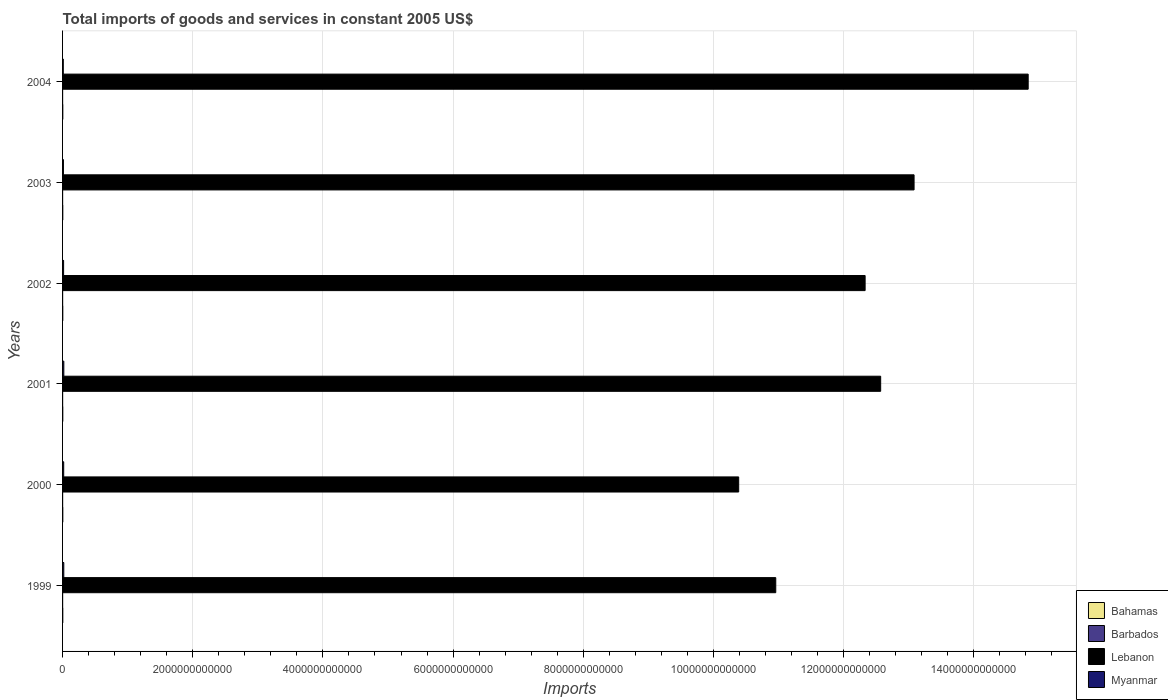How many different coloured bars are there?
Your response must be concise. 4. Are the number of bars on each tick of the Y-axis equal?
Provide a short and direct response. Yes. How many bars are there on the 1st tick from the top?
Give a very brief answer. 4. What is the total imports of goods and services in Lebanon in 1999?
Offer a very short reply. 1.10e+13. Across all years, what is the maximum total imports of goods and services in Barbados?
Ensure brevity in your answer.  8.21e+08. Across all years, what is the minimum total imports of goods and services in Lebanon?
Offer a very short reply. 1.04e+13. In which year was the total imports of goods and services in Bahamas maximum?
Your answer should be very brief. 2000. In which year was the total imports of goods and services in Bahamas minimum?
Offer a very short reply. 2002. What is the total total imports of goods and services in Lebanon in the graph?
Make the answer very short. 7.42e+13. What is the difference between the total imports of goods and services in Bahamas in 2001 and that in 2002?
Provide a succinct answer. 9.45e+07. What is the difference between the total imports of goods and services in Barbados in 2004 and the total imports of goods and services in Bahamas in 2003?
Provide a short and direct response. -2.55e+09. What is the average total imports of goods and services in Lebanon per year?
Keep it short and to the point. 1.24e+13. In the year 2003, what is the difference between the total imports of goods and services in Lebanon and total imports of goods and services in Barbados?
Your answer should be compact. 1.31e+13. What is the ratio of the total imports of goods and services in Barbados in 1999 to that in 2003?
Ensure brevity in your answer.  1.06. Is the total imports of goods and services in Lebanon in 2001 less than that in 2004?
Offer a very short reply. Yes. Is the difference between the total imports of goods and services in Lebanon in 2000 and 2004 greater than the difference between the total imports of goods and services in Barbados in 2000 and 2004?
Provide a short and direct response. No. What is the difference between the highest and the second highest total imports of goods and services in Myanmar?
Provide a succinct answer. 3.99e+08. What is the difference between the highest and the lowest total imports of goods and services in Bahamas?
Offer a terse response. 2.28e+08. In how many years, is the total imports of goods and services in Bahamas greater than the average total imports of goods and services in Bahamas taken over all years?
Ensure brevity in your answer.  3. Is the sum of the total imports of goods and services in Myanmar in 1999 and 2001 greater than the maximum total imports of goods and services in Barbados across all years?
Ensure brevity in your answer.  Yes. Is it the case that in every year, the sum of the total imports of goods and services in Myanmar and total imports of goods and services in Barbados is greater than the sum of total imports of goods and services in Lebanon and total imports of goods and services in Bahamas?
Provide a short and direct response. Yes. What does the 4th bar from the top in 2003 represents?
Provide a short and direct response. Bahamas. What does the 3rd bar from the bottom in 2002 represents?
Provide a succinct answer. Lebanon. Is it the case that in every year, the sum of the total imports of goods and services in Myanmar and total imports of goods and services in Bahamas is greater than the total imports of goods and services in Barbados?
Ensure brevity in your answer.  Yes. What is the difference between two consecutive major ticks on the X-axis?
Offer a very short reply. 2.00e+12. Does the graph contain any zero values?
Ensure brevity in your answer.  No. Where does the legend appear in the graph?
Offer a terse response. Bottom right. How many legend labels are there?
Keep it short and to the point. 4. What is the title of the graph?
Provide a short and direct response. Total imports of goods and services in constant 2005 US$. What is the label or title of the X-axis?
Make the answer very short. Imports. What is the Imports in Bahamas in 1999?
Your response must be concise. 3.36e+09. What is the Imports of Barbados in 1999?
Ensure brevity in your answer.  8.19e+08. What is the Imports of Lebanon in 1999?
Your answer should be very brief. 1.10e+13. What is the Imports of Myanmar in 1999?
Offer a very short reply. 1.90e+1. What is the Imports in Bahamas in 2000?
Ensure brevity in your answer.  3.54e+09. What is the Imports in Barbados in 2000?
Your response must be concise. 8.12e+08. What is the Imports of Lebanon in 2000?
Ensure brevity in your answer.  1.04e+13. What is the Imports of Myanmar in 2000?
Provide a succinct answer. 1.75e+1. What is the Imports of Bahamas in 2001?
Give a very brief answer. 3.41e+09. What is the Imports in Barbados in 2001?
Your answer should be very brief. 8.21e+08. What is the Imports of Lebanon in 2001?
Ensure brevity in your answer.  1.26e+13. What is the Imports in Myanmar in 2001?
Your answer should be compact. 1.94e+1. What is the Imports in Bahamas in 2002?
Provide a short and direct response. 3.32e+09. What is the Imports in Barbados in 2002?
Ensure brevity in your answer.  7.99e+08. What is the Imports in Lebanon in 2002?
Your answer should be compact. 1.23e+13. What is the Imports of Myanmar in 2002?
Make the answer very short. 1.60e+1. What is the Imports in Bahamas in 2003?
Provide a short and direct response. 3.33e+09. What is the Imports of Barbados in 2003?
Keep it short and to the point. 7.71e+08. What is the Imports in Lebanon in 2003?
Provide a short and direct response. 1.31e+13. What is the Imports in Myanmar in 2003?
Your answer should be compact. 1.35e+1. What is the Imports in Bahamas in 2004?
Give a very brief answer. 3.44e+09. What is the Imports of Barbados in 2004?
Provide a short and direct response. 7.75e+08. What is the Imports of Lebanon in 2004?
Give a very brief answer. 1.48e+13. What is the Imports of Myanmar in 2004?
Your answer should be very brief. 1.13e+1. Across all years, what is the maximum Imports in Bahamas?
Your response must be concise. 3.54e+09. Across all years, what is the maximum Imports in Barbados?
Offer a very short reply. 8.21e+08. Across all years, what is the maximum Imports in Lebanon?
Make the answer very short. 1.48e+13. Across all years, what is the maximum Imports in Myanmar?
Your answer should be very brief. 1.94e+1. Across all years, what is the minimum Imports of Bahamas?
Give a very brief answer. 3.32e+09. Across all years, what is the minimum Imports of Barbados?
Provide a short and direct response. 7.71e+08. Across all years, what is the minimum Imports of Lebanon?
Your response must be concise. 1.04e+13. Across all years, what is the minimum Imports in Myanmar?
Make the answer very short. 1.13e+1. What is the total Imports of Bahamas in the graph?
Ensure brevity in your answer.  2.04e+1. What is the total Imports in Barbados in the graph?
Offer a terse response. 4.80e+09. What is the total Imports of Lebanon in the graph?
Keep it short and to the point. 7.42e+13. What is the total Imports in Myanmar in the graph?
Give a very brief answer. 9.67e+1. What is the difference between the Imports of Bahamas in 1999 and that in 2000?
Offer a terse response. -1.84e+08. What is the difference between the Imports in Barbados in 1999 and that in 2000?
Make the answer very short. 7.00e+06. What is the difference between the Imports in Lebanon in 1999 and that in 2000?
Provide a succinct answer. 5.70e+11. What is the difference between the Imports in Myanmar in 1999 and that in 2000?
Your answer should be very brief. 1.52e+09. What is the difference between the Imports of Bahamas in 1999 and that in 2001?
Provide a short and direct response. -5.04e+07. What is the difference between the Imports of Barbados in 1999 and that in 2001?
Your answer should be very brief. -2.00e+06. What is the difference between the Imports in Lebanon in 1999 and that in 2001?
Provide a succinct answer. -1.61e+12. What is the difference between the Imports in Myanmar in 1999 and that in 2001?
Offer a very short reply. -3.99e+08. What is the difference between the Imports in Bahamas in 1999 and that in 2002?
Give a very brief answer. 4.41e+07. What is the difference between the Imports in Barbados in 1999 and that in 2002?
Give a very brief answer. 2.00e+07. What is the difference between the Imports of Lebanon in 1999 and that in 2002?
Your answer should be compact. -1.37e+12. What is the difference between the Imports of Myanmar in 1999 and that in 2002?
Offer a terse response. 3.00e+09. What is the difference between the Imports in Bahamas in 1999 and that in 2003?
Make the answer very short. 3.28e+07. What is the difference between the Imports of Barbados in 1999 and that in 2003?
Your answer should be very brief. 4.80e+07. What is the difference between the Imports in Lebanon in 1999 and that in 2003?
Give a very brief answer. -2.12e+12. What is the difference between the Imports in Myanmar in 1999 and that in 2003?
Offer a very short reply. 5.53e+09. What is the difference between the Imports of Bahamas in 1999 and that in 2004?
Ensure brevity in your answer.  -8.50e+07. What is the difference between the Imports in Barbados in 1999 and that in 2004?
Provide a succinct answer. 4.40e+07. What is the difference between the Imports of Lebanon in 1999 and that in 2004?
Keep it short and to the point. -3.88e+12. What is the difference between the Imports in Myanmar in 1999 and that in 2004?
Provide a short and direct response. 7.72e+09. What is the difference between the Imports in Bahamas in 2000 and that in 2001?
Keep it short and to the point. 1.34e+08. What is the difference between the Imports of Barbados in 2000 and that in 2001?
Offer a very short reply. -9.00e+06. What is the difference between the Imports in Lebanon in 2000 and that in 2001?
Offer a terse response. -2.18e+12. What is the difference between the Imports of Myanmar in 2000 and that in 2001?
Offer a terse response. -1.92e+09. What is the difference between the Imports of Bahamas in 2000 and that in 2002?
Your response must be concise. 2.28e+08. What is the difference between the Imports in Barbados in 2000 and that in 2002?
Ensure brevity in your answer.  1.30e+07. What is the difference between the Imports in Lebanon in 2000 and that in 2002?
Your response must be concise. -1.94e+12. What is the difference between the Imports of Myanmar in 2000 and that in 2002?
Offer a very short reply. 1.48e+09. What is the difference between the Imports of Bahamas in 2000 and that in 2003?
Keep it short and to the point. 2.17e+08. What is the difference between the Imports in Barbados in 2000 and that in 2003?
Offer a terse response. 4.10e+07. What is the difference between the Imports in Lebanon in 2000 and that in 2003?
Provide a succinct answer. -2.69e+12. What is the difference between the Imports of Myanmar in 2000 and that in 2003?
Offer a terse response. 4.01e+09. What is the difference between the Imports of Bahamas in 2000 and that in 2004?
Offer a terse response. 9.93e+07. What is the difference between the Imports of Barbados in 2000 and that in 2004?
Keep it short and to the point. 3.70e+07. What is the difference between the Imports of Lebanon in 2000 and that in 2004?
Make the answer very short. -4.45e+12. What is the difference between the Imports of Myanmar in 2000 and that in 2004?
Provide a short and direct response. 6.20e+09. What is the difference between the Imports of Bahamas in 2001 and that in 2002?
Make the answer very short. 9.45e+07. What is the difference between the Imports of Barbados in 2001 and that in 2002?
Provide a succinct answer. 2.20e+07. What is the difference between the Imports in Lebanon in 2001 and that in 2002?
Give a very brief answer. 2.39e+11. What is the difference between the Imports in Myanmar in 2001 and that in 2002?
Provide a short and direct response. 3.40e+09. What is the difference between the Imports in Bahamas in 2001 and that in 2003?
Provide a short and direct response. 8.32e+07. What is the difference between the Imports of Lebanon in 2001 and that in 2003?
Give a very brief answer. -5.13e+11. What is the difference between the Imports of Myanmar in 2001 and that in 2003?
Provide a short and direct response. 5.93e+09. What is the difference between the Imports of Bahamas in 2001 and that in 2004?
Make the answer very short. -3.46e+07. What is the difference between the Imports in Barbados in 2001 and that in 2004?
Offer a very short reply. 4.60e+07. What is the difference between the Imports in Lebanon in 2001 and that in 2004?
Provide a succinct answer. -2.27e+12. What is the difference between the Imports of Myanmar in 2001 and that in 2004?
Your answer should be very brief. 8.12e+09. What is the difference between the Imports of Bahamas in 2002 and that in 2003?
Provide a succinct answer. -1.13e+07. What is the difference between the Imports in Barbados in 2002 and that in 2003?
Your answer should be very brief. 2.80e+07. What is the difference between the Imports in Lebanon in 2002 and that in 2003?
Offer a terse response. -7.52e+11. What is the difference between the Imports of Myanmar in 2002 and that in 2003?
Your answer should be compact. 2.53e+09. What is the difference between the Imports of Bahamas in 2002 and that in 2004?
Your response must be concise. -1.29e+08. What is the difference between the Imports in Barbados in 2002 and that in 2004?
Offer a terse response. 2.40e+07. What is the difference between the Imports in Lebanon in 2002 and that in 2004?
Your answer should be very brief. -2.51e+12. What is the difference between the Imports of Myanmar in 2002 and that in 2004?
Make the answer very short. 4.72e+09. What is the difference between the Imports of Bahamas in 2003 and that in 2004?
Offer a very short reply. -1.18e+08. What is the difference between the Imports in Lebanon in 2003 and that in 2004?
Provide a short and direct response. -1.75e+12. What is the difference between the Imports of Myanmar in 2003 and that in 2004?
Provide a succinct answer. 2.19e+09. What is the difference between the Imports in Bahamas in 1999 and the Imports in Barbados in 2000?
Ensure brevity in your answer.  2.55e+09. What is the difference between the Imports of Bahamas in 1999 and the Imports of Lebanon in 2000?
Give a very brief answer. -1.04e+13. What is the difference between the Imports in Bahamas in 1999 and the Imports in Myanmar in 2000?
Keep it short and to the point. -1.41e+1. What is the difference between the Imports of Barbados in 1999 and the Imports of Lebanon in 2000?
Make the answer very short. -1.04e+13. What is the difference between the Imports in Barbados in 1999 and the Imports in Myanmar in 2000?
Ensure brevity in your answer.  -1.67e+1. What is the difference between the Imports in Lebanon in 1999 and the Imports in Myanmar in 2000?
Your answer should be very brief. 1.09e+13. What is the difference between the Imports of Bahamas in 1999 and the Imports of Barbados in 2001?
Keep it short and to the point. 2.54e+09. What is the difference between the Imports of Bahamas in 1999 and the Imports of Lebanon in 2001?
Make the answer very short. -1.26e+13. What is the difference between the Imports in Bahamas in 1999 and the Imports in Myanmar in 2001?
Ensure brevity in your answer.  -1.61e+1. What is the difference between the Imports of Barbados in 1999 and the Imports of Lebanon in 2001?
Your response must be concise. -1.26e+13. What is the difference between the Imports in Barbados in 1999 and the Imports in Myanmar in 2001?
Your answer should be very brief. -1.86e+1. What is the difference between the Imports in Lebanon in 1999 and the Imports in Myanmar in 2001?
Offer a terse response. 1.09e+13. What is the difference between the Imports of Bahamas in 1999 and the Imports of Barbados in 2002?
Offer a very short reply. 2.56e+09. What is the difference between the Imports of Bahamas in 1999 and the Imports of Lebanon in 2002?
Your answer should be very brief. -1.23e+13. What is the difference between the Imports in Bahamas in 1999 and the Imports in Myanmar in 2002?
Ensure brevity in your answer.  -1.27e+1. What is the difference between the Imports of Barbados in 1999 and the Imports of Lebanon in 2002?
Ensure brevity in your answer.  -1.23e+13. What is the difference between the Imports of Barbados in 1999 and the Imports of Myanmar in 2002?
Offer a very short reply. -1.52e+1. What is the difference between the Imports of Lebanon in 1999 and the Imports of Myanmar in 2002?
Your answer should be compact. 1.09e+13. What is the difference between the Imports in Bahamas in 1999 and the Imports in Barbados in 2003?
Offer a terse response. 2.59e+09. What is the difference between the Imports in Bahamas in 1999 and the Imports in Lebanon in 2003?
Provide a short and direct response. -1.31e+13. What is the difference between the Imports in Bahamas in 1999 and the Imports in Myanmar in 2003?
Your response must be concise. -1.01e+1. What is the difference between the Imports in Barbados in 1999 and the Imports in Lebanon in 2003?
Your answer should be compact. -1.31e+13. What is the difference between the Imports of Barbados in 1999 and the Imports of Myanmar in 2003?
Give a very brief answer. -1.27e+1. What is the difference between the Imports in Lebanon in 1999 and the Imports in Myanmar in 2003?
Ensure brevity in your answer.  1.09e+13. What is the difference between the Imports of Bahamas in 1999 and the Imports of Barbados in 2004?
Make the answer very short. 2.58e+09. What is the difference between the Imports of Bahamas in 1999 and the Imports of Lebanon in 2004?
Offer a very short reply. -1.48e+13. What is the difference between the Imports of Bahamas in 1999 and the Imports of Myanmar in 2004?
Make the answer very short. -7.94e+09. What is the difference between the Imports of Barbados in 1999 and the Imports of Lebanon in 2004?
Your answer should be very brief. -1.48e+13. What is the difference between the Imports of Barbados in 1999 and the Imports of Myanmar in 2004?
Ensure brevity in your answer.  -1.05e+1. What is the difference between the Imports in Lebanon in 1999 and the Imports in Myanmar in 2004?
Offer a very short reply. 1.09e+13. What is the difference between the Imports of Bahamas in 2000 and the Imports of Barbados in 2001?
Your answer should be very brief. 2.72e+09. What is the difference between the Imports of Bahamas in 2000 and the Imports of Lebanon in 2001?
Ensure brevity in your answer.  -1.26e+13. What is the difference between the Imports in Bahamas in 2000 and the Imports in Myanmar in 2001?
Provide a short and direct response. -1.59e+1. What is the difference between the Imports in Barbados in 2000 and the Imports in Lebanon in 2001?
Make the answer very short. -1.26e+13. What is the difference between the Imports in Barbados in 2000 and the Imports in Myanmar in 2001?
Provide a short and direct response. -1.86e+1. What is the difference between the Imports in Lebanon in 2000 and the Imports in Myanmar in 2001?
Ensure brevity in your answer.  1.04e+13. What is the difference between the Imports of Bahamas in 2000 and the Imports of Barbados in 2002?
Offer a terse response. 2.75e+09. What is the difference between the Imports of Bahamas in 2000 and the Imports of Lebanon in 2002?
Your answer should be compact. -1.23e+13. What is the difference between the Imports of Bahamas in 2000 and the Imports of Myanmar in 2002?
Keep it short and to the point. -1.25e+1. What is the difference between the Imports in Barbados in 2000 and the Imports in Lebanon in 2002?
Offer a very short reply. -1.23e+13. What is the difference between the Imports of Barbados in 2000 and the Imports of Myanmar in 2002?
Provide a short and direct response. -1.52e+1. What is the difference between the Imports of Lebanon in 2000 and the Imports of Myanmar in 2002?
Offer a terse response. 1.04e+13. What is the difference between the Imports of Bahamas in 2000 and the Imports of Barbados in 2003?
Your response must be concise. 2.77e+09. What is the difference between the Imports in Bahamas in 2000 and the Imports in Lebanon in 2003?
Make the answer very short. -1.31e+13. What is the difference between the Imports in Bahamas in 2000 and the Imports in Myanmar in 2003?
Ensure brevity in your answer.  -9.94e+09. What is the difference between the Imports of Barbados in 2000 and the Imports of Lebanon in 2003?
Provide a succinct answer. -1.31e+13. What is the difference between the Imports of Barbados in 2000 and the Imports of Myanmar in 2003?
Ensure brevity in your answer.  -1.27e+1. What is the difference between the Imports of Lebanon in 2000 and the Imports of Myanmar in 2003?
Give a very brief answer. 1.04e+13. What is the difference between the Imports of Bahamas in 2000 and the Imports of Barbados in 2004?
Offer a terse response. 2.77e+09. What is the difference between the Imports in Bahamas in 2000 and the Imports in Lebanon in 2004?
Make the answer very short. -1.48e+13. What is the difference between the Imports in Bahamas in 2000 and the Imports in Myanmar in 2004?
Provide a succinct answer. -7.76e+09. What is the difference between the Imports of Barbados in 2000 and the Imports of Lebanon in 2004?
Ensure brevity in your answer.  -1.48e+13. What is the difference between the Imports in Barbados in 2000 and the Imports in Myanmar in 2004?
Make the answer very short. -1.05e+1. What is the difference between the Imports of Lebanon in 2000 and the Imports of Myanmar in 2004?
Keep it short and to the point. 1.04e+13. What is the difference between the Imports of Bahamas in 2001 and the Imports of Barbados in 2002?
Make the answer very short. 2.61e+09. What is the difference between the Imports of Bahamas in 2001 and the Imports of Lebanon in 2002?
Make the answer very short. -1.23e+13. What is the difference between the Imports of Bahamas in 2001 and the Imports of Myanmar in 2002?
Your answer should be compact. -1.26e+1. What is the difference between the Imports of Barbados in 2001 and the Imports of Lebanon in 2002?
Make the answer very short. -1.23e+13. What is the difference between the Imports in Barbados in 2001 and the Imports in Myanmar in 2002?
Your answer should be very brief. -1.52e+1. What is the difference between the Imports of Lebanon in 2001 and the Imports of Myanmar in 2002?
Your answer should be very brief. 1.26e+13. What is the difference between the Imports in Bahamas in 2001 and the Imports in Barbados in 2003?
Ensure brevity in your answer.  2.64e+09. What is the difference between the Imports of Bahamas in 2001 and the Imports of Lebanon in 2003?
Your answer should be compact. -1.31e+13. What is the difference between the Imports of Bahamas in 2001 and the Imports of Myanmar in 2003?
Give a very brief answer. -1.01e+1. What is the difference between the Imports of Barbados in 2001 and the Imports of Lebanon in 2003?
Ensure brevity in your answer.  -1.31e+13. What is the difference between the Imports in Barbados in 2001 and the Imports in Myanmar in 2003?
Offer a terse response. -1.27e+1. What is the difference between the Imports in Lebanon in 2001 and the Imports in Myanmar in 2003?
Your response must be concise. 1.26e+13. What is the difference between the Imports of Bahamas in 2001 and the Imports of Barbados in 2004?
Your response must be concise. 2.64e+09. What is the difference between the Imports in Bahamas in 2001 and the Imports in Lebanon in 2004?
Keep it short and to the point. -1.48e+13. What is the difference between the Imports of Bahamas in 2001 and the Imports of Myanmar in 2004?
Give a very brief answer. -7.89e+09. What is the difference between the Imports in Barbados in 2001 and the Imports in Lebanon in 2004?
Make the answer very short. -1.48e+13. What is the difference between the Imports of Barbados in 2001 and the Imports of Myanmar in 2004?
Your response must be concise. -1.05e+1. What is the difference between the Imports of Lebanon in 2001 and the Imports of Myanmar in 2004?
Provide a short and direct response. 1.26e+13. What is the difference between the Imports in Bahamas in 2002 and the Imports in Barbados in 2003?
Make the answer very short. 2.54e+09. What is the difference between the Imports of Bahamas in 2002 and the Imports of Lebanon in 2003?
Keep it short and to the point. -1.31e+13. What is the difference between the Imports in Bahamas in 2002 and the Imports in Myanmar in 2003?
Keep it short and to the point. -1.02e+1. What is the difference between the Imports of Barbados in 2002 and the Imports of Lebanon in 2003?
Your answer should be very brief. -1.31e+13. What is the difference between the Imports of Barbados in 2002 and the Imports of Myanmar in 2003?
Your answer should be very brief. -1.27e+1. What is the difference between the Imports in Lebanon in 2002 and the Imports in Myanmar in 2003?
Your answer should be very brief. 1.23e+13. What is the difference between the Imports of Bahamas in 2002 and the Imports of Barbados in 2004?
Give a very brief answer. 2.54e+09. What is the difference between the Imports in Bahamas in 2002 and the Imports in Lebanon in 2004?
Keep it short and to the point. -1.48e+13. What is the difference between the Imports in Bahamas in 2002 and the Imports in Myanmar in 2004?
Provide a succinct answer. -7.98e+09. What is the difference between the Imports of Barbados in 2002 and the Imports of Lebanon in 2004?
Ensure brevity in your answer.  -1.48e+13. What is the difference between the Imports of Barbados in 2002 and the Imports of Myanmar in 2004?
Your answer should be compact. -1.05e+1. What is the difference between the Imports in Lebanon in 2002 and the Imports in Myanmar in 2004?
Offer a terse response. 1.23e+13. What is the difference between the Imports of Bahamas in 2003 and the Imports of Barbados in 2004?
Make the answer very short. 2.55e+09. What is the difference between the Imports in Bahamas in 2003 and the Imports in Lebanon in 2004?
Offer a very short reply. -1.48e+13. What is the difference between the Imports of Bahamas in 2003 and the Imports of Myanmar in 2004?
Keep it short and to the point. -7.97e+09. What is the difference between the Imports in Barbados in 2003 and the Imports in Lebanon in 2004?
Your answer should be very brief. -1.48e+13. What is the difference between the Imports in Barbados in 2003 and the Imports in Myanmar in 2004?
Give a very brief answer. -1.05e+1. What is the difference between the Imports in Lebanon in 2003 and the Imports in Myanmar in 2004?
Keep it short and to the point. 1.31e+13. What is the average Imports in Bahamas per year?
Your response must be concise. 3.40e+09. What is the average Imports of Barbados per year?
Keep it short and to the point. 8.00e+08. What is the average Imports of Lebanon per year?
Offer a very short reply. 1.24e+13. What is the average Imports in Myanmar per year?
Provide a short and direct response. 1.61e+1. In the year 1999, what is the difference between the Imports of Bahamas and Imports of Barbados?
Your response must be concise. 2.54e+09. In the year 1999, what is the difference between the Imports in Bahamas and Imports in Lebanon?
Your answer should be very brief. -1.10e+13. In the year 1999, what is the difference between the Imports of Bahamas and Imports of Myanmar?
Make the answer very short. -1.57e+1. In the year 1999, what is the difference between the Imports in Barbados and Imports in Lebanon?
Offer a very short reply. -1.10e+13. In the year 1999, what is the difference between the Imports of Barbados and Imports of Myanmar?
Offer a terse response. -1.82e+1. In the year 1999, what is the difference between the Imports of Lebanon and Imports of Myanmar?
Ensure brevity in your answer.  1.09e+13. In the year 2000, what is the difference between the Imports in Bahamas and Imports in Barbados?
Provide a succinct answer. 2.73e+09. In the year 2000, what is the difference between the Imports of Bahamas and Imports of Lebanon?
Offer a very short reply. -1.04e+13. In the year 2000, what is the difference between the Imports in Bahamas and Imports in Myanmar?
Your answer should be very brief. -1.40e+1. In the year 2000, what is the difference between the Imports in Barbados and Imports in Lebanon?
Provide a short and direct response. -1.04e+13. In the year 2000, what is the difference between the Imports of Barbados and Imports of Myanmar?
Provide a short and direct response. -1.67e+1. In the year 2000, what is the difference between the Imports of Lebanon and Imports of Myanmar?
Provide a short and direct response. 1.04e+13. In the year 2001, what is the difference between the Imports in Bahamas and Imports in Barbados?
Offer a very short reply. 2.59e+09. In the year 2001, what is the difference between the Imports of Bahamas and Imports of Lebanon?
Keep it short and to the point. -1.26e+13. In the year 2001, what is the difference between the Imports in Bahamas and Imports in Myanmar?
Provide a succinct answer. -1.60e+1. In the year 2001, what is the difference between the Imports of Barbados and Imports of Lebanon?
Provide a succinct answer. -1.26e+13. In the year 2001, what is the difference between the Imports of Barbados and Imports of Myanmar?
Offer a very short reply. -1.86e+1. In the year 2001, what is the difference between the Imports of Lebanon and Imports of Myanmar?
Give a very brief answer. 1.25e+13. In the year 2002, what is the difference between the Imports in Bahamas and Imports in Barbados?
Your answer should be very brief. 2.52e+09. In the year 2002, what is the difference between the Imports in Bahamas and Imports in Lebanon?
Provide a succinct answer. -1.23e+13. In the year 2002, what is the difference between the Imports of Bahamas and Imports of Myanmar?
Your answer should be compact. -1.27e+1. In the year 2002, what is the difference between the Imports in Barbados and Imports in Lebanon?
Keep it short and to the point. -1.23e+13. In the year 2002, what is the difference between the Imports of Barbados and Imports of Myanmar?
Provide a succinct answer. -1.52e+1. In the year 2002, what is the difference between the Imports in Lebanon and Imports in Myanmar?
Offer a very short reply. 1.23e+13. In the year 2003, what is the difference between the Imports of Bahamas and Imports of Barbados?
Provide a succinct answer. 2.56e+09. In the year 2003, what is the difference between the Imports of Bahamas and Imports of Lebanon?
Offer a terse response. -1.31e+13. In the year 2003, what is the difference between the Imports in Bahamas and Imports in Myanmar?
Provide a short and direct response. -1.02e+1. In the year 2003, what is the difference between the Imports of Barbados and Imports of Lebanon?
Provide a short and direct response. -1.31e+13. In the year 2003, what is the difference between the Imports in Barbados and Imports in Myanmar?
Ensure brevity in your answer.  -1.27e+1. In the year 2003, what is the difference between the Imports of Lebanon and Imports of Myanmar?
Offer a very short reply. 1.31e+13. In the year 2004, what is the difference between the Imports of Bahamas and Imports of Barbados?
Offer a very short reply. 2.67e+09. In the year 2004, what is the difference between the Imports in Bahamas and Imports in Lebanon?
Give a very brief answer. -1.48e+13. In the year 2004, what is the difference between the Imports of Bahamas and Imports of Myanmar?
Provide a short and direct response. -7.86e+09. In the year 2004, what is the difference between the Imports in Barbados and Imports in Lebanon?
Provide a succinct answer. -1.48e+13. In the year 2004, what is the difference between the Imports in Barbados and Imports in Myanmar?
Make the answer very short. -1.05e+1. In the year 2004, what is the difference between the Imports in Lebanon and Imports in Myanmar?
Provide a short and direct response. 1.48e+13. What is the ratio of the Imports of Bahamas in 1999 to that in 2000?
Provide a succinct answer. 0.95. What is the ratio of the Imports in Barbados in 1999 to that in 2000?
Your answer should be very brief. 1.01. What is the ratio of the Imports in Lebanon in 1999 to that in 2000?
Give a very brief answer. 1.05. What is the ratio of the Imports in Myanmar in 1999 to that in 2000?
Your answer should be compact. 1.09. What is the ratio of the Imports in Bahamas in 1999 to that in 2001?
Provide a short and direct response. 0.99. What is the ratio of the Imports in Lebanon in 1999 to that in 2001?
Offer a very short reply. 0.87. What is the ratio of the Imports of Myanmar in 1999 to that in 2001?
Your answer should be very brief. 0.98. What is the ratio of the Imports in Bahamas in 1999 to that in 2002?
Make the answer very short. 1.01. What is the ratio of the Imports in Barbados in 1999 to that in 2002?
Your answer should be very brief. 1.02. What is the ratio of the Imports in Lebanon in 1999 to that in 2002?
Offer a very short reply. 0.89. What is the ratio of the Imports in Myanmar in 1999 to that in 2002?
Make the answer very short. 1.19. What is the ratio of the Imports in Bahamas in 1999 to that in 2003?
Provide a short and direct response. 1.01. What is the ratio of the Imports in Barbados in 1999 to that in 2003?
Provide a succinct answer. 1.06. What is the ratio of the Imports of Lebanon in 1999 to that in 2003?
Offer a terse response. 0.84. What is the ratio of the Imports of Myanmar in 1999 to that in 2003?
Your answer should be very brief. 1.41. What is the ratio of the Imports of Bahamas in 1999 to that in 2004?
Make the answer very short. 0.98. What is the ratio of the Imports in Barbados in 1999 to that in 2004?
Offer a terse response. 1.06. What is the ratio of the Imports in Lebanon in 1999 to that in 2004?
Make the answer very short. 0.74. What is the ratio of the Imports of Myanmar in 1999 to that in 2004?
Provide a succinct answer. 1.68. What is the ratio of the Imports of Bahamas in 2000 to that in 2001?
Your response must be concise. 1.04. What is the ratio of the Imports of Barbados in 2000 to that in 2001?
Keep it short and to the point. 0.99. What is the ratio of the Imports in Lebanon in 2000 to that in 2001?
Your response must be concise. 0.83. What is the ratio of the Imports of Myanmar in 2000 to that in 2001?
Offer a terse response. 0.9. What is the ratio of the Imports of Bahamas in 2000 to that in 2002?
Give a very brief answer. 1.07. What is the ratio of the Imports in Barbados in 2000 to that in 2002?
Your response must be concise. 1.02. What is the ratio of the Imports in Lebanon in 2000 to that in 2002?
Make the answer very short. 0.84. What is the ratio of the Imports in Myanmar in 2000 to that in 2002?
Offer a terse response. 1.09. What is the ratio of the Imports of Bahamas in 2000 to that in 2003?
Offer a very short reply. 1.07. What is the ratio of the Imports of Barbados in 2000 to that in 2003?
Your answer should be compact. 1.05. What is the ratio of the Imports in Lebanon in 2000 to that in 2003?
Your response must be concise. 0.79. What is the ratio of the Imports in Myanmar in 2000 to that in 2003?
Offer a terse response. 1.3. What is the ratio of the Imports in Bahamas in 2000 to that in 2004?
Ensure brevity in your answer.  1.03. What is the ratio of the Imports in Barbados in 2000 to that in 2004?
Provide a short and direct response. 1.05. What is the ratio of the Imports in Lebanon in 2000 to that in 2004?
Your answer should be very brief. 0.7. What is the ratio of the Imports of Myanmar in 2000 to that in 2004?
Offer a very short reply. 1.55. What is the ratio of the Imports of Bahamas in 2001 to that in 2002?
Offer a very short reply. 1.03. What is the ratio of the Imports of Barbados in 2001 to that in 2002?
Provide a succinct answer. 1.03. What is the ratio of the Imports in Lebanon in 2001 to that in 2002?
Give a very brief answer. 1.02. What is the ratio of the Imports of Myanmar in 2001 to that in 2002?
Ensure brevity in your answer.  1.21. What is the ratio of the Imports in Barbados in 2001 to that in 2003?
Provide a succinct answer. 1.06. What is the ratio of the Imports in Lebanon in 2001 to that in 2003?
Your answer should be very brief. 0.96. What is the ratio of the Imports of Myanmar in 2001 to that in 2003?
Offer a terse response. 1.44. What is the ratio of the Imports of Bahamas in 2001 to that in 2004?
Your answer should be very brief. 0.99. What is the ratio of the Imports of Barbados in 2001 to that in 2004?
Your answer should be compact. 1.06. What is the ratio of the Imports in Lebanon in 2001 to that in 2004?
Ensure brevity in your answer.  0.85. What is the ratio of the Imports in Myanmar in 2001 to that in 2004?
Offer a terse response. 1.72. What is the ratio of the Imports of Bahamas in 2002 to that in 2003?
Your answer should be compact. 1. What is the ratio of the Imports of Barbados in 2002 to that in 2003?
Your response must be concise. 1.04. What is the ratio of the Imports of Lebanon in 2002 to that in 2003?
Provide a short and direct response. 0.94. What is the ratio of the Imports of Myanmar in 2002 to that in 2003?
Provide a succinct answer. 1.19. What is the ratio of the Imports of Bahamas in 2002 to that in 2004?
Give a very brief answer. 0.96. What is the ratio of the Imports in Barbados in 2002 to that in 2004?
Ensure brevity in your answer.  1.03. What is the ratio of the Imports of Lebanon in 2002 to that in 2004?
Provide a short and direct response. 0.83. What is the ratio of the Imports in Myanmar in 2002 to that in 2004?
Ensure brevity in your answer.  1.42. What is the ratio of the Imports of Bahamas in 2003 to that in 2004?
Your response must be concise. 0.97. What is the ratio of the Imports of Barbados in 2003 to that in 2004?
Offer a very short reply. 0.99. What is the ratio of the Imports of Lebanon in 2003 to that in 2004?
Ensure brevity in your answer.  0.88. What is the ratio of the Imports in Myanmar in 2003 to that in 2004?
Offer a terse response. 1.19. What is the difference between the highest and the second highest Imports of Bahamas?
Your answer should be compact. 9.93e+07. What is the difference between the highest and the second highest Imports in Lebanon?
Your response must be concise. 1.75e+12. What is the difference between the highest and the second highest Imports of Myanmar?
Your answer should be very brief. 3.99e+08. What is the difference between the highest and the lowest Imports of Bahamas?
Your answer should be very brief. 2.28e+08. What is the difference between the highest and the lowest Imports in Barbados?
Make the answer very short. 5.00e+07. What is the difference between the highest and the lowest Imports of Lebanon?
Provide a succinct answer. 4.45e+12. What is the difference between the highest and the lowest Imports in Myanmar?
Offer a very short reply. 8.12e+09. 